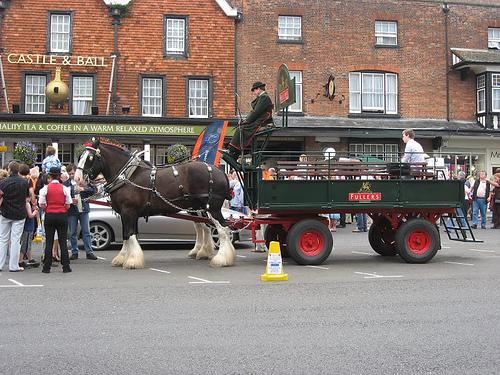What color are the bearings inside of the wagon wheels? Please explain your reasoning. red. The color is red. 